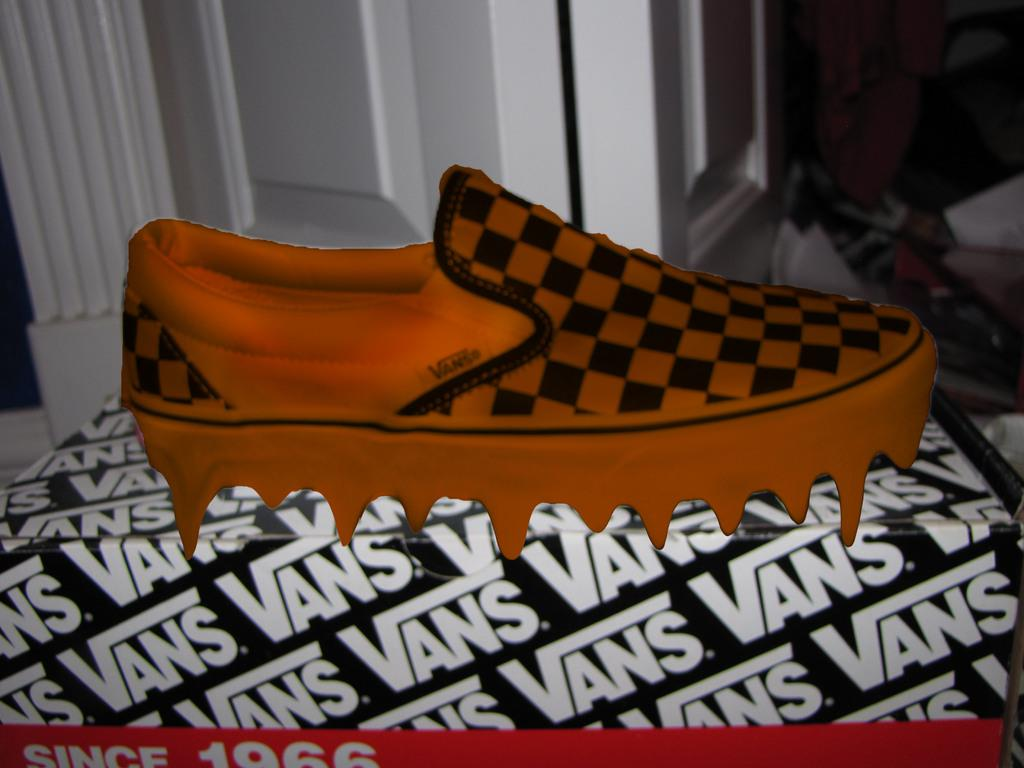What is the main subject of the picture? The main subject of the picture is an animated image of a shoe. Can you describe the shoe in the image? Unfortunately, the facts provided do not give any details about the appearance or characteristics of the shoe. How does the daughter feel about the river and its religious significance in the image? There is no daughter, river, or religious significance present in the image. The image only contains an animated image of a shoe. 